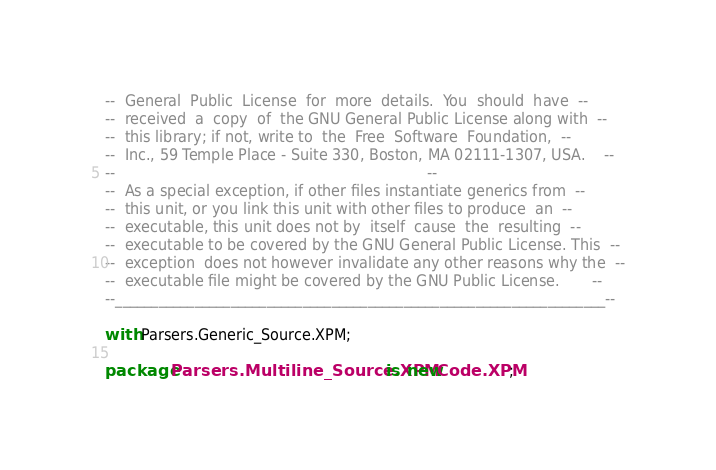Convert code to text. <code><loc_0><loc_0><loc_500><loc_500><_Ada_>--  General  Public  License  for  more  details.  You  should  have  --
--  received  a  copy  of  the GNU General Public License along with  --
--  this library; if not, write to  the  Free  Software  Foundation,  --
--  Inc., 59 Temple Place - Suite 330, Boston, MA 02111-1307, USA.    --
--                                                                    --
--  As a special exception, if other files instantiate generics from  --
--  this unit, or you link this unit with other files to produce  an  --
--  executable, this unit does not by  itself  cause  the  resulting  --
--  executable to be covered by the GNU General Public License. This  --
--  exception  does not however invalidate any other reasons why the  --
--  executable file might be covered by the GNU Public License.       --
--____________________________________________________________________--

with Parsers.Generic_Source.XPM;
 
package Parsers.Multiline_Source.XPM is new Code.XPM;
</code> 